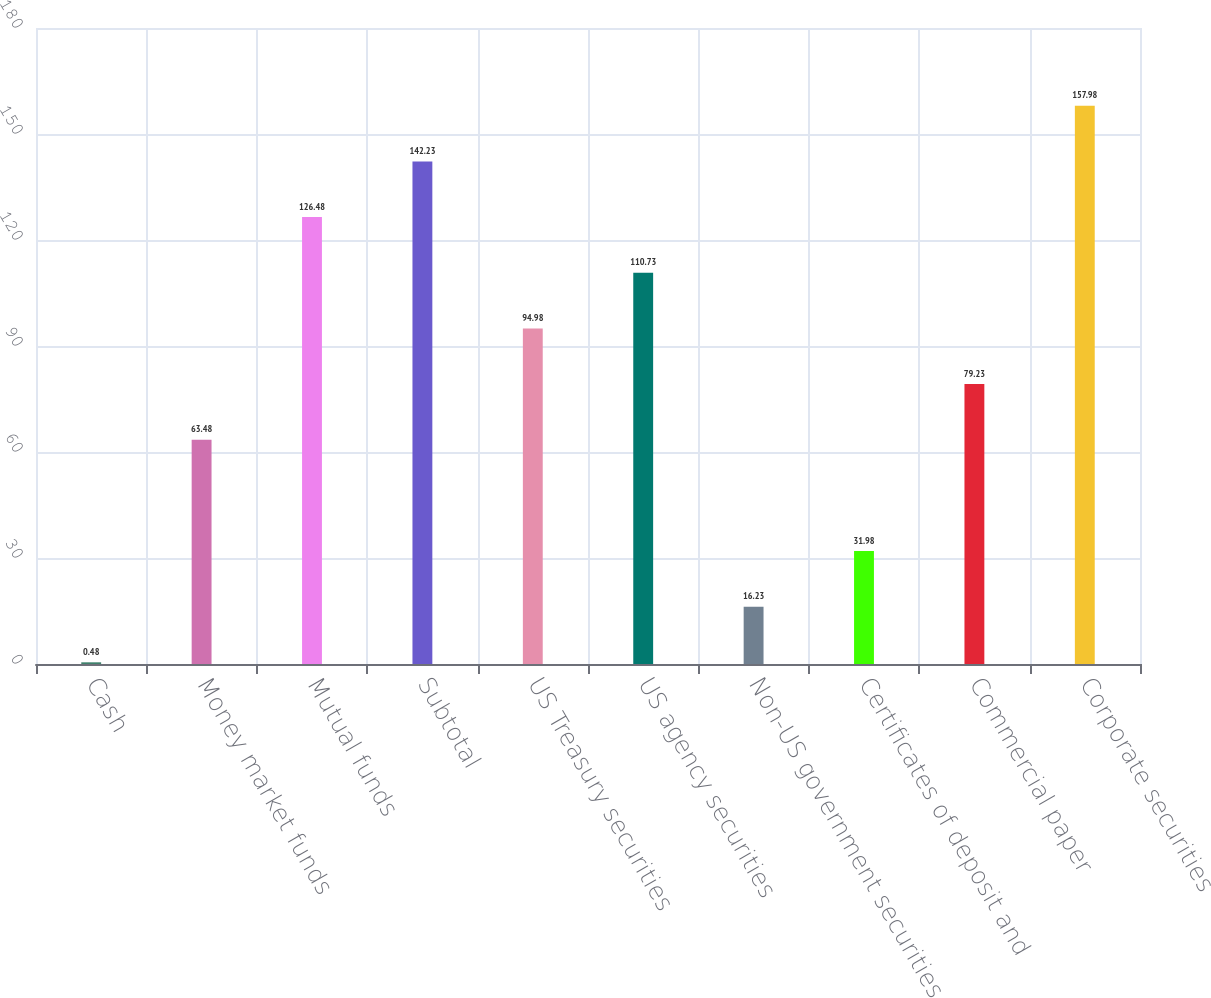Convert chart. <chart><loc_0><loc_0><loc_500><loc_500><bar_chart><fcel>Cash<fcel>Money market funds<fcel>Mutual funds<fcel>Subtotal<fcel>US Treasury securities<fcel>US agency securities<fcel>Non-US government securities<fcel>Certificates of deposit and<fcel>Commercial paper<fcel>Corporate securities<nl><fcel>0.48<fcel>63.48<fcel>126.48<fcel>142.23<fcel>94.98<fcel>110.73<fcel>16.23<fcel>31.98<fcel>79.23<fcel>157.98<nl></chart> 